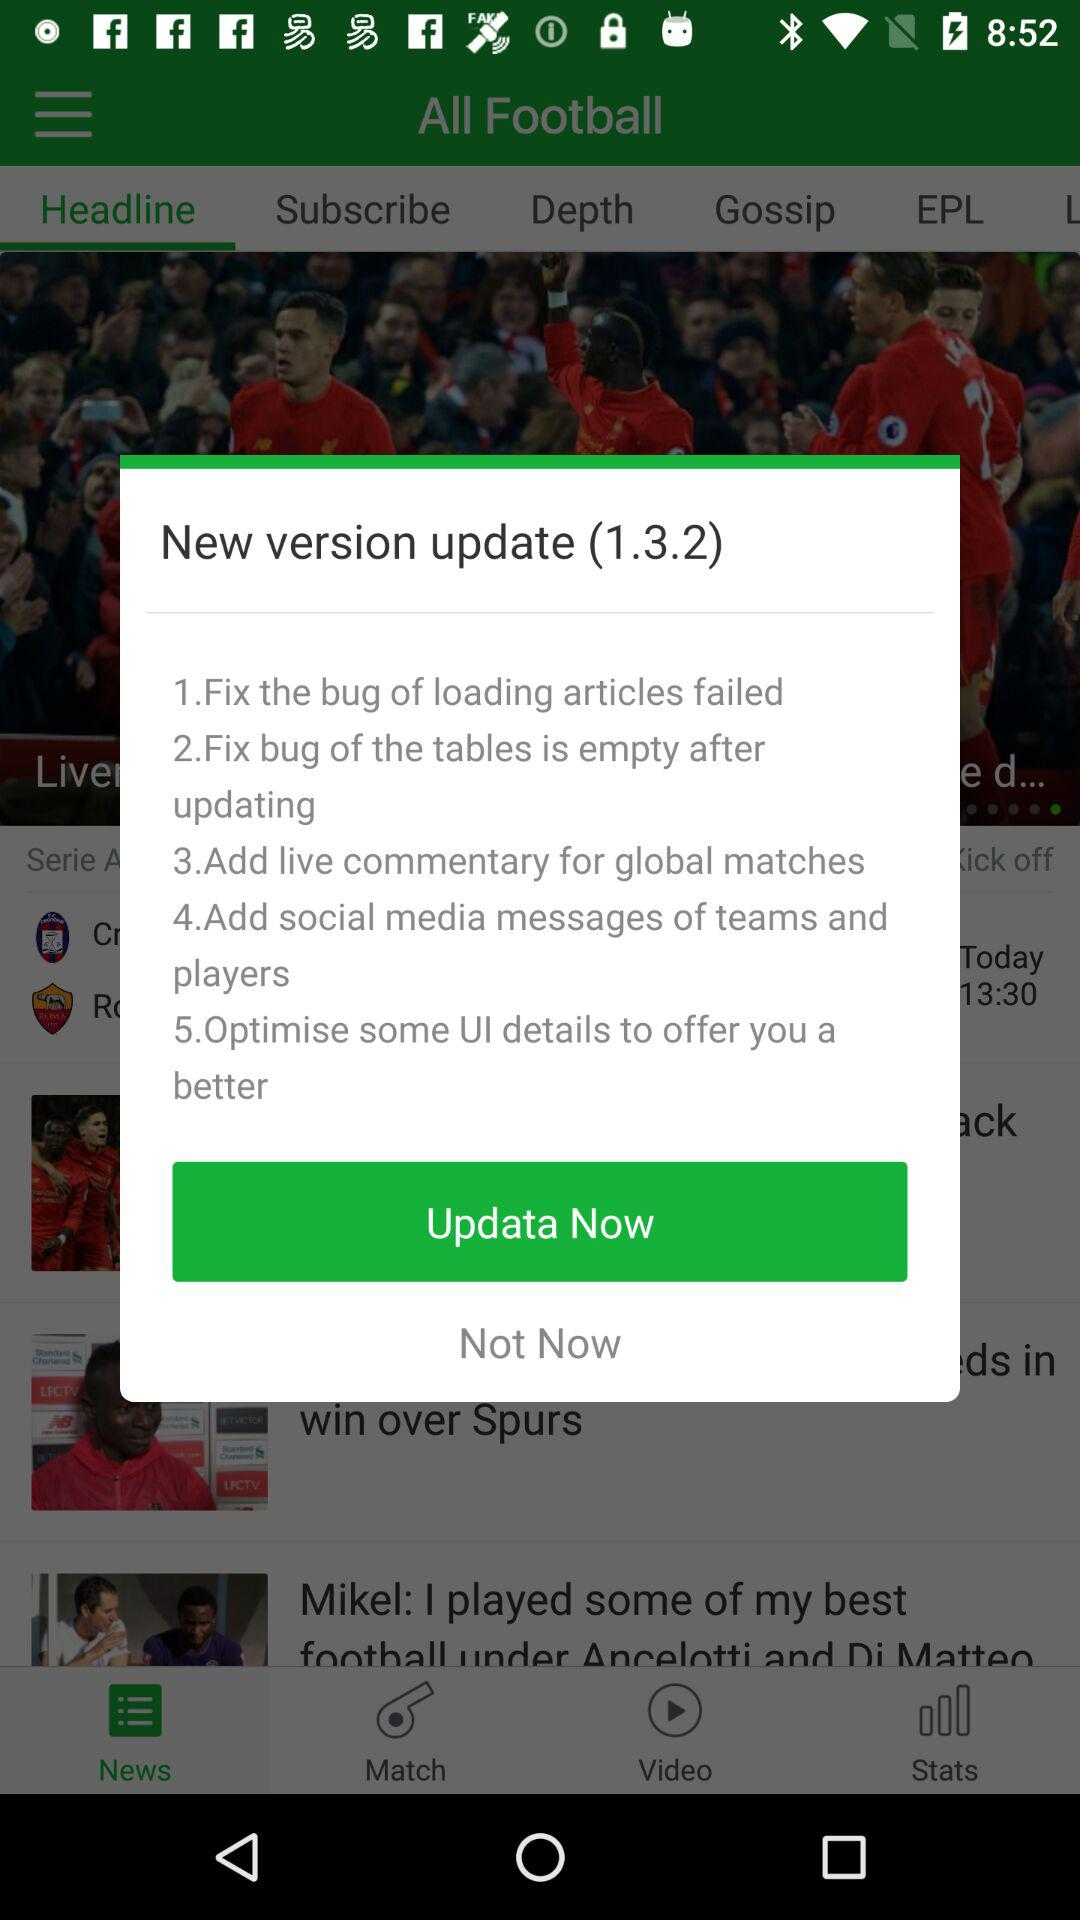How many bug fixes are mentioned in the update?
Answer the question using a single word or phrase. 2 